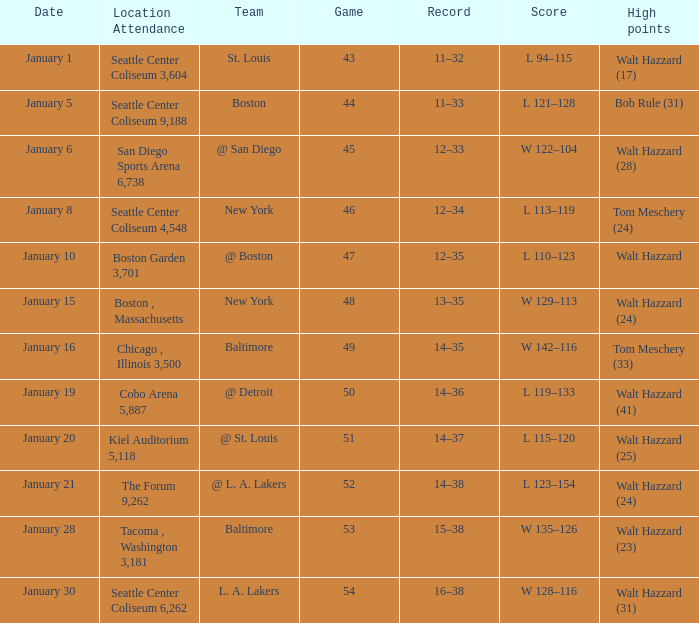Can you parse all the data within this table? {'header': ['Date', 'Location Attendance', 'Team', 'Game', 'Record', 'Score', 'High points'], 'rows': [['January 1', 'Seattle Center Coliseum 3,604', 'St. Louis', '43', '11–32', 'L 94–115', 'Walt Hazzard (17)'], ['January 5', 'Seattle Center Coliseum 9,188', 'Boston', '44', '11–33', 'L 121–128', 'Bob Rule (31)'], ['January 6', 'San Diego Sports Arena 6,738', '@ San Diego', '45', '12–33', 'W 122–104', 'Walt Hazzard (28)'], ['January 8', 'Seattle Center Coliseum 4,548', 'New York', '46', '12–34', 'L 113–119', 'Tom Meschery (24)'], ['January 10', 'Boston Garden 3,701', '@ Boston', '47', '12–35', 'L 110–123', 'Walt Hazzard'], ['January 15', 'Boston , Massachusetts', 'New York', '48', '13–35', 'W 129–113', 'Walt Hazzard (24)'], ['January 16', 'Chicago , Illinois 3,500', 'Baltimore', '49', '14–35', 'W 142–116', 'Tom Meschery (33)'], ['January 19', 'Cobo Arena 5,887', '@ Detroit', '50', '14–36', 'L 119–133', 'Walt Hazzard (41)'], ['January 20', 'Kiel Auditorium 5,118', '@ St. Louis', '51', '14–37', 'L 115–120', 'Walt Hazzard (25)'], ['January 21', 'The Forum 9,262', '@ L. A. Lakers', '52', '14–38', 'L 123–154', 'Walt Hazzard (24)'], ['January 28', 'Tacoma , Washington 3,181', 'Baltimore', '53', '15–38', 'W 135–126', 'Walt Hazzard (23)'], ['January 30', 'Seattle Center Coliseum 6,262', 'L. A. Lakers', '54', '16–38', 'W 128–116', 'Walt Hazzard (31)']]} What is the record for the St. Louis team? 11–32. 